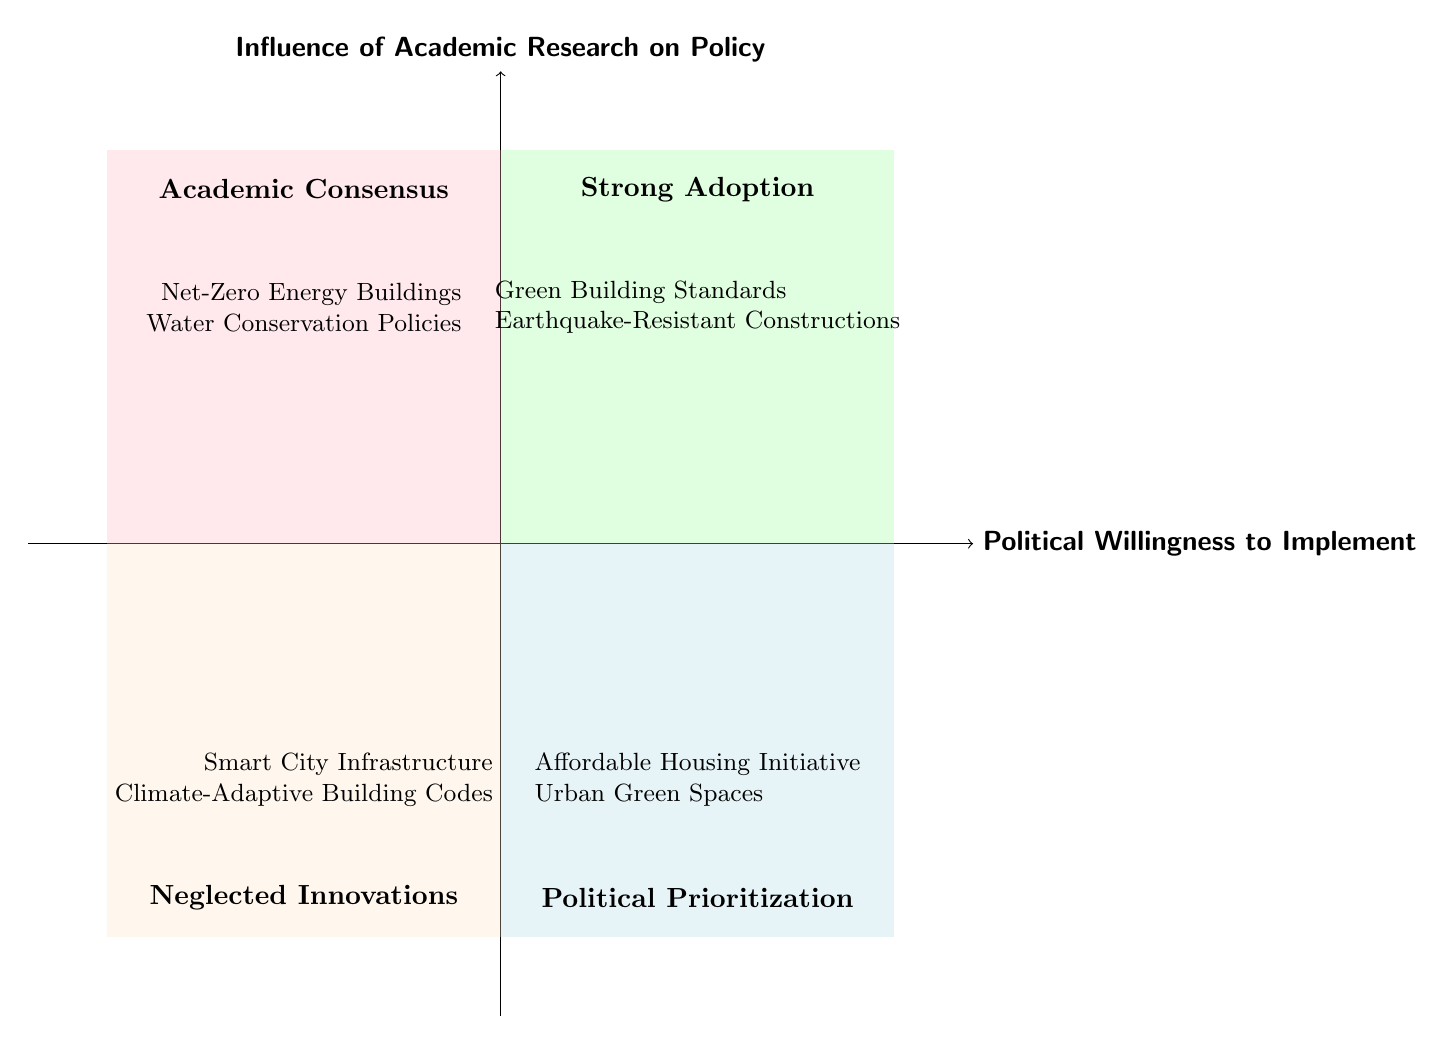What is the title of the top-left quadrant? The title for the top-left quadrant (High Influence, Low Willingness) is "Academic Consensus," which can be found by checking the diagram for the label in that specific section.
Answer: Academic Consensus How many policies are listed in the "Strong Adoption" quadrant? In the "Strong Adoption" quadrant (top-right), there are two policies mentioned: Green Building Standards and Earthquake-Resistant Constructions, hence the total count is two.
Answer: 2 Which quadrant contains the "Climate-Adaptive Building Codes"? The "Climate-Adaptive Building Codes" policy is found in the bottom-left quadrant (Low Influence, Low Willingness), as indicated by its inclusion in that specific section of the diagram.
Answer: Neglected Innovations What type of policies are described in the "Political Prioritization" quadrant? The "Political Prioritization" quadrant (bottom-right) includes policies that indicate a high political willingness but lower influence from research. The two specific examples are the Affordable Housing Initiative and Urban Green Spaces, which align with this theme.
Answer: Affordable Housing Initiative and Urban Green Spaces Identify one research source listed under "Net-Zero Energy Buildings." The research source associated with "Net-Zero Energy Buildings" is the sustainability research conducted by Stanford University, as noted alongside that policy in the "Academic Consensus" quadrant.
Answer: Sustainability Research by Stanford University How many examples are provided in the "Neglected Innovations" quadrant? The "Neglected Innovations" quadrant contains two examples, Smart City Infrastructure and Climate-Adaptive Building Codes, which can be verified by counting them within that section's listing.
Answer: 2 What is the relationship between "Political Willingness" and "Influence" in the "Strong Adoption" quadrant? In the "Strong Adoption" quadrant, the relationship indicates high political willingness to implement policies alongside a significant influence from academic research, as both parameters are positioned in the high range of the respective axes.
Answer: High Influence and High Willingness What are the implications of having policies in the "Academic Consensus" quadrant? Policies in the "Academic Consensus" quadrant indicate that there is strong research backing for these policies (High Influence) but little political willingness to implement them, suggesting a gap between research and practical implementation.
Answer: High Influence, Low Willingness 